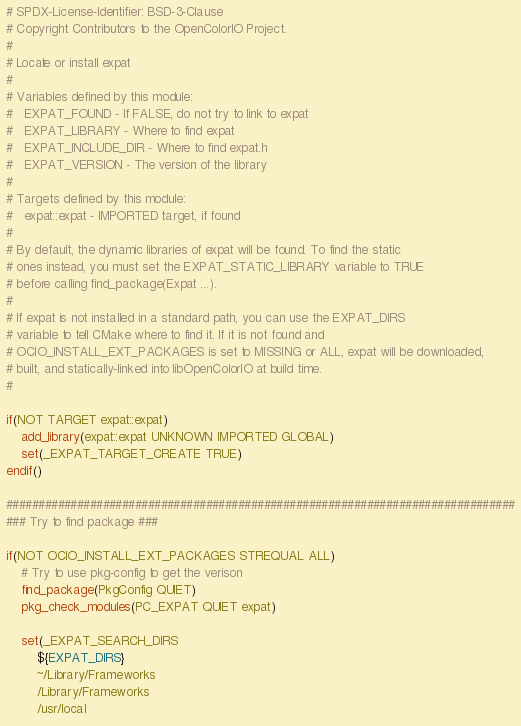<code> <loc_0><loc_0><loc_500><loc_500><_CMake_># SPDX-License-Identifier: BSD-3-Clause
# Copyright Contributors to the OpenColorIO Project.
#
# Locate or install expat
#
# Variables defined by this module:
#   EXPAT_FOUND - If FALSE, do not try to link to expat
#   EXPAT_LIBRARY - Where to find expat
#   EXPAT_INCLUDE_DIR - Where to find expat.h
#   EXPAT_VERSION - The version of the library
#
# Targets defined by this module:
#   expat::expat - IMPORTED target, if found
#
# By default, the dynamic libraries of expat will be found. To find the static 
# ones instead, you must set the EXPAT_STATIC_LIBRARY variable to TRUE 
# before calling find_package(Expat ...).
#
# If expat is not installed in a standard path, you can use the EXPAT_DIRS 
# variable to tell CMake where to find it. If it is not found and 
# OCIO_INSTALL_EXT_PACKAGES is set to MISSING or ALL, expat will be downloaded, 
# built, and statically-linked into libOpenColorIO at build time.
#

if(NOT TARGET expat::expat)
    add_library(expat::expat UNKNOWN IMPORTED GLOBAL)
    set(_EXPAT_TARGET_CREATE TRUE)
endif()

###############################################################################
### Try to find package ###

if(NOT OCIO_INSTALL_EXT_PACKAGES STREQUAL ALL)
    # Try to use pkg-config to get the verison
    find_package(PkgConfig QUIET)
    pkg_check_modules(PC_EXPAT QUIET expat)

    set(_EXPAT_SEARCH_DIRS
        ${EXPAT_DIRS}
        ~/Library/Frameworks
        /Library/Frameworks
        /usr/local</code> 